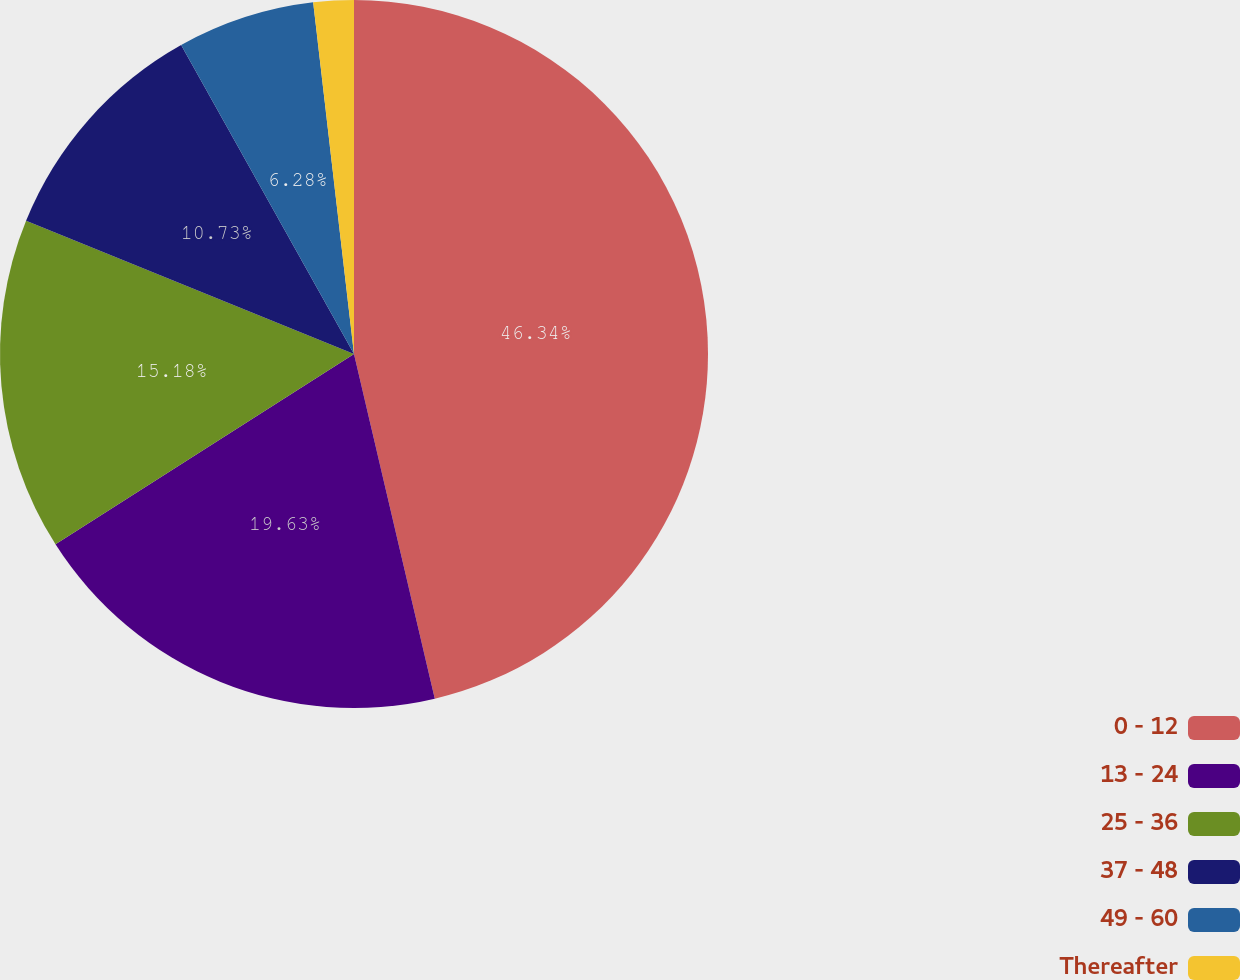Convert chart. <chart><loc_0><loc_0><loc_500><loc_500><pie_chart><fcel>0 - 12<fcel>13 - 24<fcel>25 - 36<fcel>37 - 48<fcel>49 - 60<fcel>Thereafter<nl><fcel>46.33%<fcel>19.63%<fcel>15.18%<fcel>10.73%<fcel>6.28%<fcel>1.84%<nl></chart> 